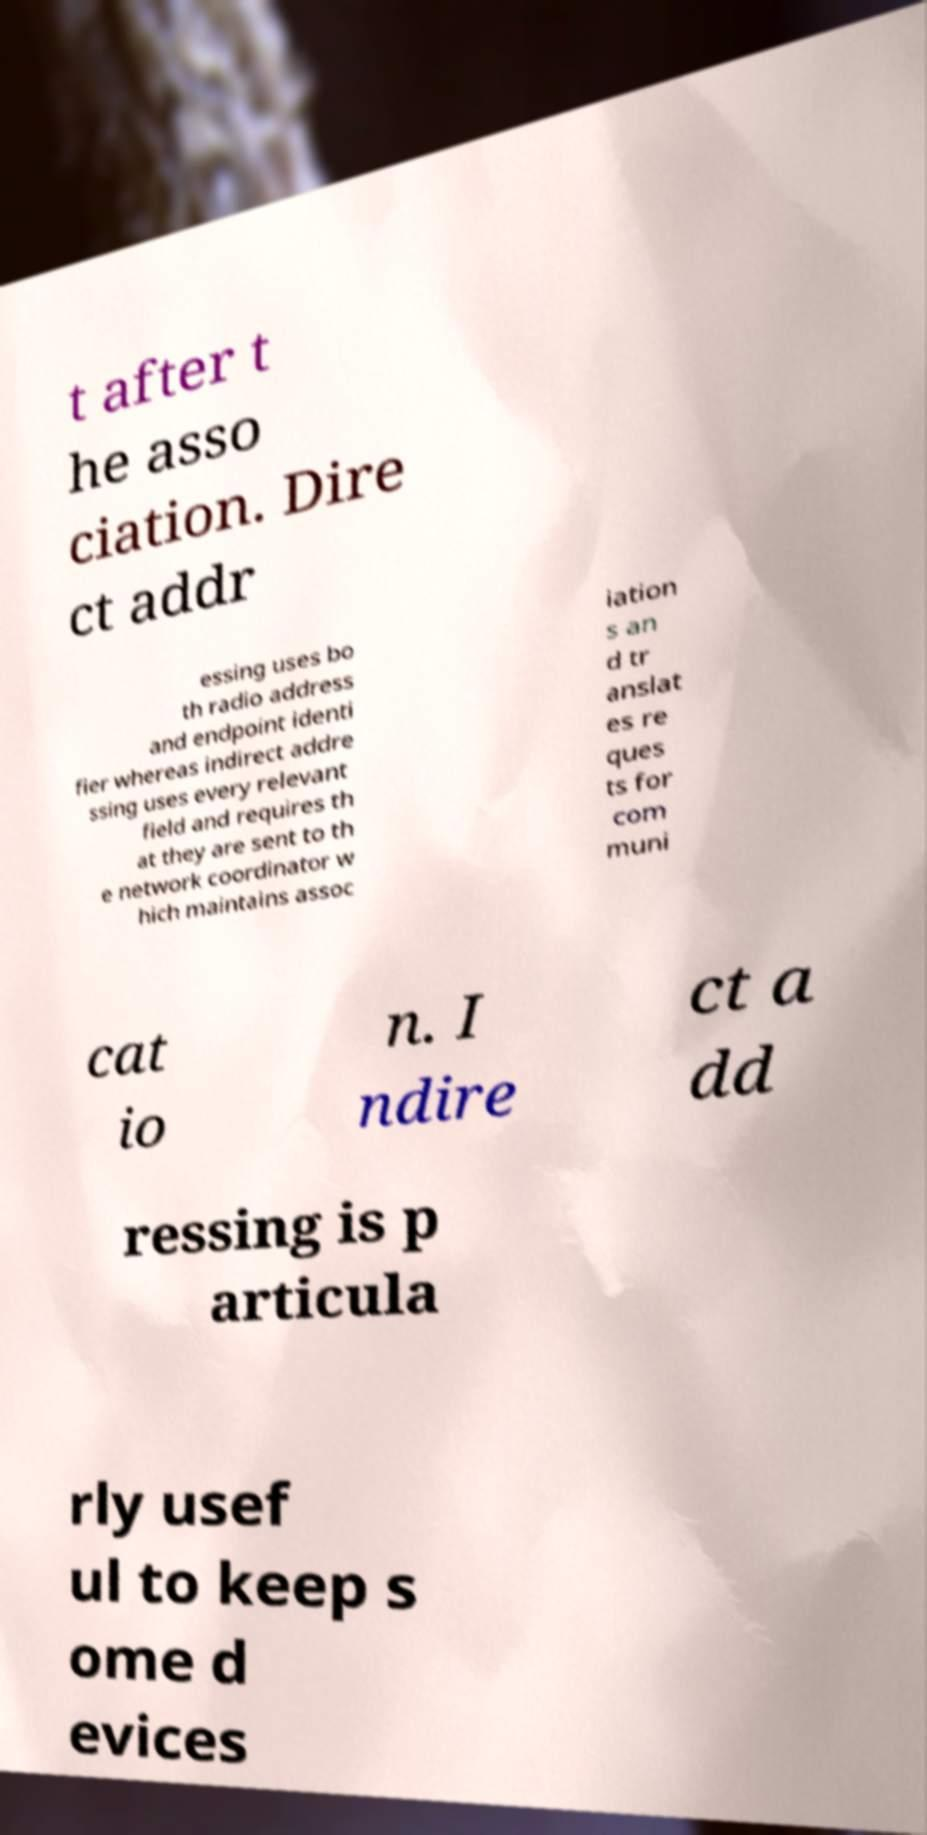Could you extract and type out the text from this image? t after t he asso ciation. Dire ct addr essing uses bo th radio address and endpoint identi fier whereas indirect addre ssing uses every relevant field and requires th at they are sent to th e network coordinator w hich maintains assoc iation s an d tr anslat es re ques ts for com muni cat io n. I ndire ct a dd ressing is p articula rly usef ul to keep s ome d evices 